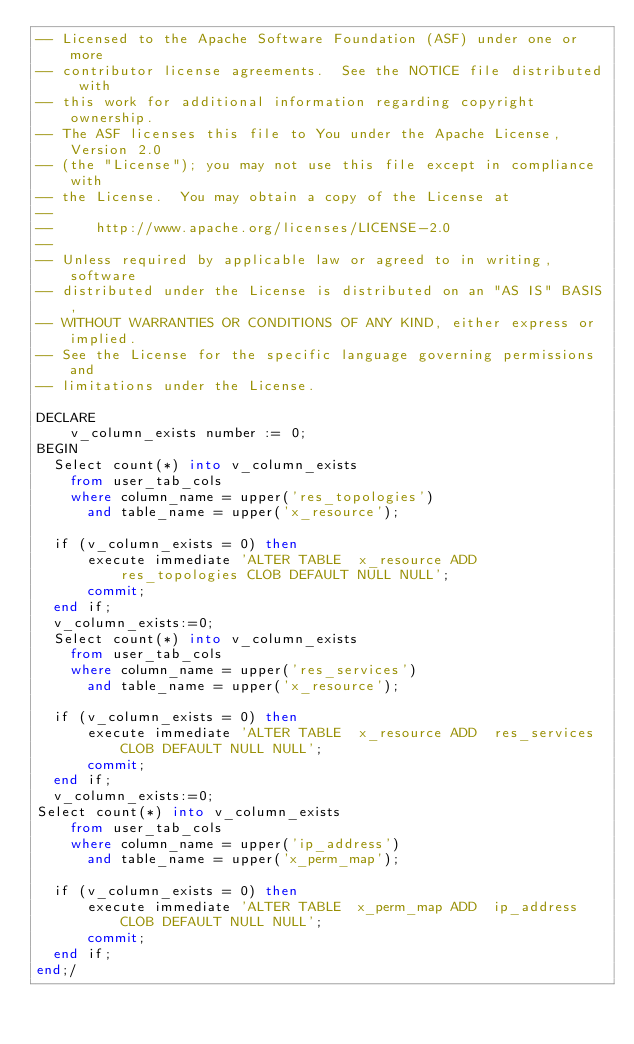<code> <loc_0><loc_0><loc_500><loc_500><_SQL_>-- Licensed to the Apache Software Foundation (ASF) under one or more
-- contributor license agreements.  See the NOTICE file distributed with
-- this work for additional information regarding copyright ownership.
-- The ASF licenses this file to You under the Apache License, Version 2.0
-- (the "License"); you may not use this file except in compliance with
-- the License.  You may obtain a copy of the License at
--
--     http://www.apache.org/licenses/LICENSE-2.0
--
-- Unless required by applicable law or agreed to in writing, software
-- distributed under the License is distributed on an "AS IS" BASIS,
-- WITHOUT WARRANTIES OR CONDITIONS OF ANY KIND, either express or implied.
-- See the License for the specific language governing permissions and
-- limitations under the License.

DECLARE
	v_column_exists number := 0;
BEGIN
  Select count(*) into v_column_exists
    from user_tab_cols
    where column_name = upper('res_topologies')
      and table_name = upper('x_resource');

  if (v_column_exists = 0) then
      execute immediate 'ALTER TABLE  x_resource ADD  res_topologies CLOB DEFAULT NULL NULL';
      commit;
  end if;
  v_column_exists:=0;
  Select count(*) into v_column_exists
    from user_tab_cols
    where column_name = upper('res_services')
      and table_name = upper('x_resource');

  if (v_column_exists = 0) then
      execute immediate 'ALTER TABLE  x_resource ADD  res_services CLOB DEFAULT NULL NULL';
      commit;
  end if;
  v_column_exists:=0;
Select count(*) into v_column_exists
    from user_tab_cols
    where column_name = upper('ip_address')
      and table_name = upper('x_perm_map');

  if (v_column_exists = 0) then
      execute immediate 'ALTER TABLE  x_perm_map ADD  ip_address CLOB DEFAULT NULL NULL';
      commit;
  end if;
end;/</code> 